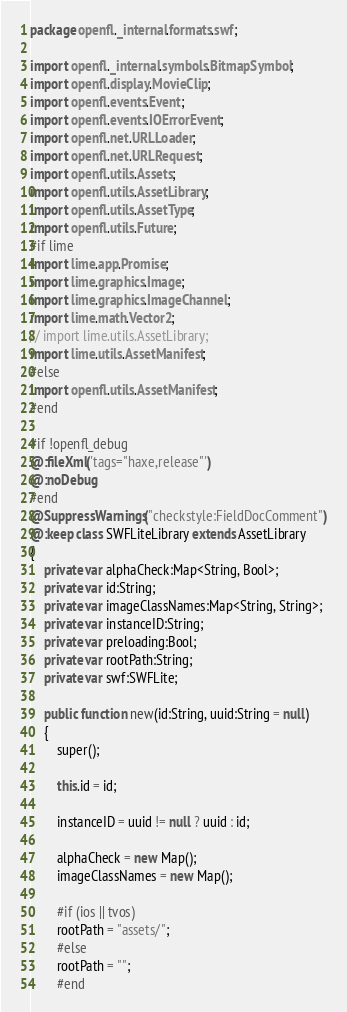<code> <loc_0><loc_0><loc_500><loc_500><_Haxe_>package openfl._internal.formats.swf;

import openfl._internal.symbols.BitmapSymbol;
import openfl.display.MovieClip;
import openfl.events.Event;
import openfl.events.IOErrorEvent;
import openfl.net.URLLoader;
import openfl.net.URLRequest;
import openfl.utils.Assets;
import openfl.utils.AssetLibrary;
import openfl.utils.AssetType;
import openfl.utils.Future;
#if lime
import lime.app.Promise;
import lime.graphics.Image;
import lime.graphics.ImageChannel;
import lime.math.Vector2;
// import lime.utils.AssetLibrary;
import lime.utils.AssetManifest;
#else
import openfl.utils.AssetManifest;
#end

#if !openfl_debug
@:fileXml('tags="haxe,release"')
@:noDebug
#end
@SuppressWarnings("checkstyle:FieldDocComment")
@:keep class SWFLiteLibrary extends AssetLibrary
{
	private var alphaCheck:Map<String, Bool>;
	private var id:String;
	private var imageClassNames:Map<String, String>;
	private var instanceID:String;
	private var preloading:Bool;
	private var rootPath:String;
	private var swf:SWFLite;

	public function new(id:String, uuid:String = null)
	{
		super();

		this.id = id;

		instanceID = uuid != null ? uuid : id;

		alphaCheck = new Map();
		imageClassNames = new Map();

		#if (ios || tvos)
		rootPath = "assets/";
		#else
		rootPath = "";
		#end
</code> 